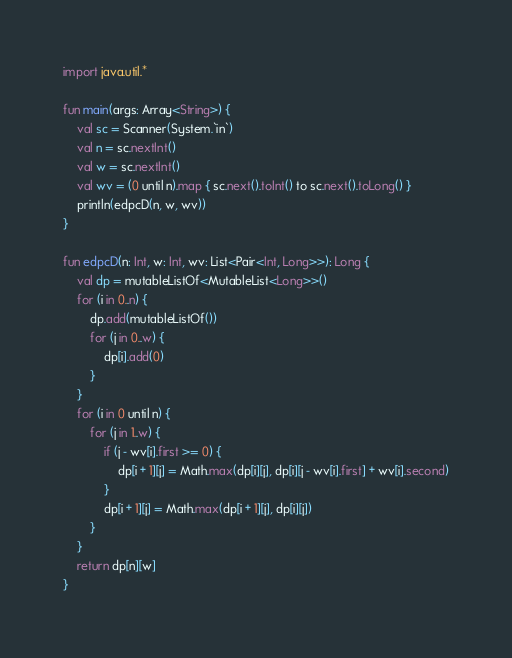<code> <loc_0><loc_0><loc_500><loc_500><_Kotlin_>import java.util.*

fun main(args: Array<String>) {
    val sc = Scanner(System.`in`)
    val n = sc.nextInt()
    val w = sc.nextInt()
    val wv = (0 until n).map { sc.next().toInt() to sc.next().toLong() }
    println(edpcD(n, w, wv))
}

fun edpcD(n: Int, w: Int, wv: List<Pair<Int, Long>>): Long {
    val dp = mutableListOf<MutableList<Long>>()
    for (i in 0..n) {
        dp.add(mutableListOf())
        for (j in 0..w) {
            dp[i].add(0)
        }
    }
    for (i in 0 until n) {
        for (j in 1..w) {
            if (j - wv[i].first >= 0) {
                dp[i + 1][j] = Math.max(dp[i][j], dp[i][j - wv[i].first] + wv[i].second)
            }
            dp[i + 1][j] = Math.max(dp[i + 1][j], dp[i][j])
        }
    }
    return dp[n][w]
}</code> 